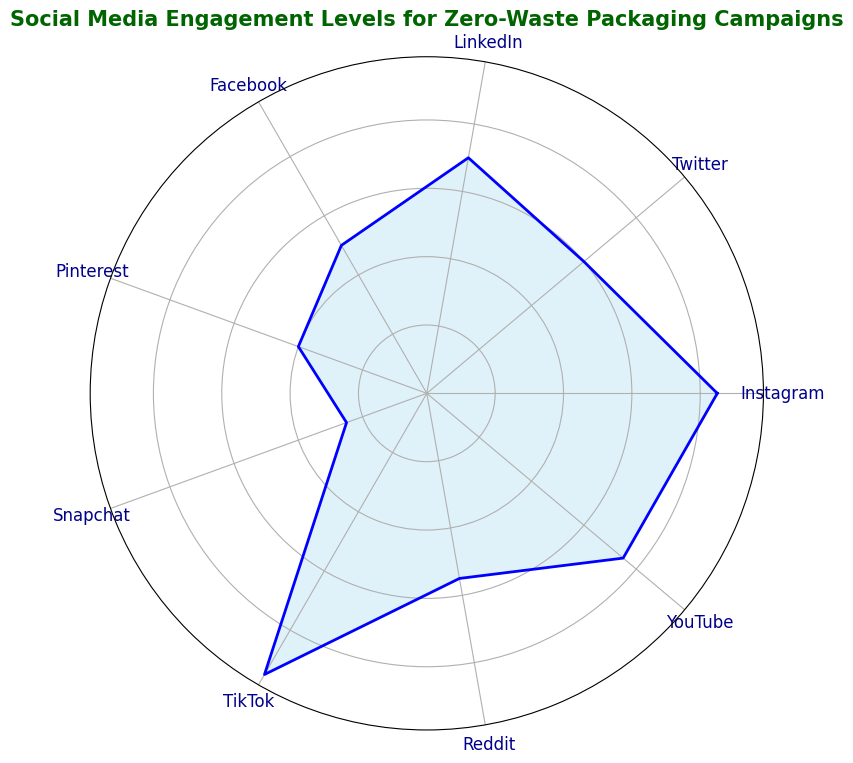What's the platform with the highest engagement level? By observing the chart, TikTok has the largest area indicating the highest engagement level among all platforms.
Answer: TikTok Which platform has the lowest engagement level? From the polar chart, Snapchat has the smallest area, indicating it has the lowest engagement level.
Answer: Snapchat Compare the engagement levels of Instagram and Twitter. Which one is higher? Instagram and Twitter are both shown on the chart with their respective areas. Instagram has a larger area representing an engagement level of 85, whereas Twitter has a smaller area representing an engagement level of 60.
Answer: Instagram What is the average engagement level across all platforms represented? To find the average, sum the engagement levels and divide by the number of platforms. (85 + 60 + 70 + 50 + 40 + 25 + 95 + 55 + 75) / 9 = 61.67.
Answer: 61.67 How much higher is TikTok's engagement level compared to LinkedIn's? TikTok's engagement level is 95, and LinkedIn's is 70. Subtract LinkedIn's engagement level from TikTok's to find the difference: 95 - 70 = 25.
Answer: 25 Identify two platforms with engagement levels that sum to 130. Observing the chart, YouTube and LinkedIn have engagement levels of 75 and 55, respectively. Summing these gives 75 + 55 = 130.
Answer: YouTube and LinkedIn Which platform's engagement level is closest to the median? The median value for odd numbers of data points is the middle value when sorted. The sorted engagement levels are [25, 40, 50, 55, 60, 70, 75, 85, 95], so the median is 60. Twitter's engagement level is 60, exactly the median.
Answer: Twitter Compare the engagement levels of Facebook and Reddit. How much greater is one than the other? Facebook's engagement level is 50, and Reddit's is 55. Reddit's engagement is greater: 55 - 50 = 5.
Answer: 5 How do YouTube's and Instagram's engagement levels compare proportionally? YouTube's engagement level is 75, and Instagram's is 85. The ratio of YouTube's engagement to Instagram's is 75/85 = 0.88.
Answer: 0.88 